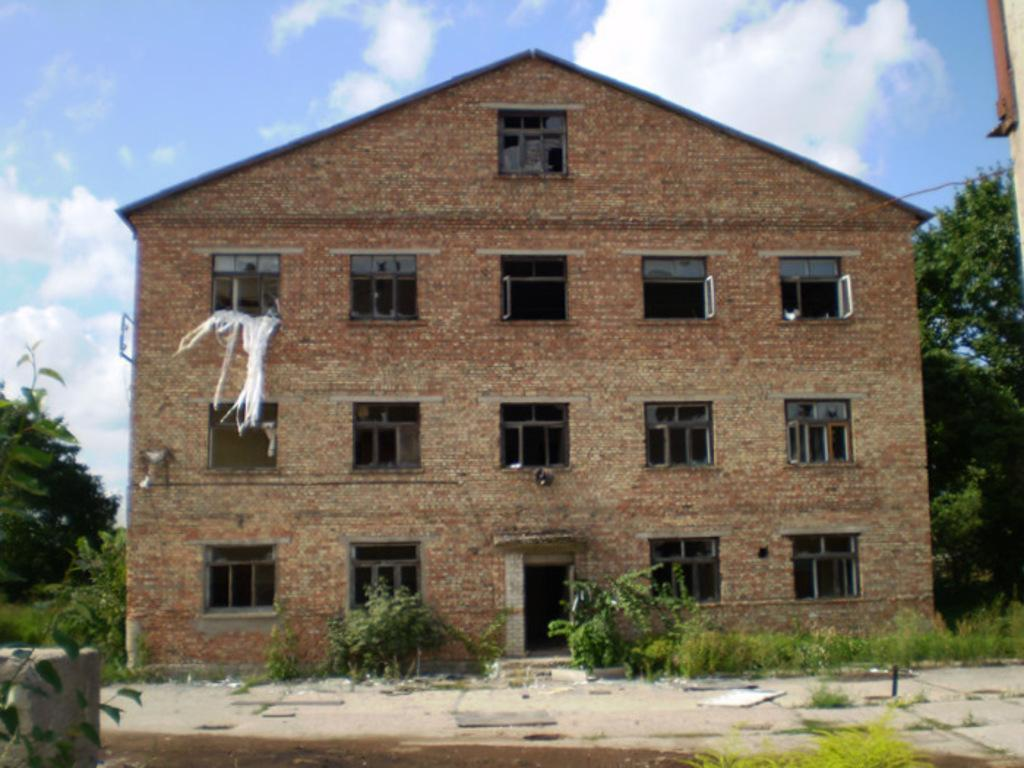What type of structure is present in the image? There is a building in the image. What type of vegetation can be seen in the image? There are plants, grass, and trees in the image. Is there a designated walking area in the image? Yes, there is a path in the image. What can be seen in the background of the image? The sky is visible in the background of the image, and there are clouds in the sky. What type of honey is being harvested from the trees in the image? There is no honey or honey harvesting depicted in the image; it features a building, plants, grass, trees, a path, and a sky with clouds. 